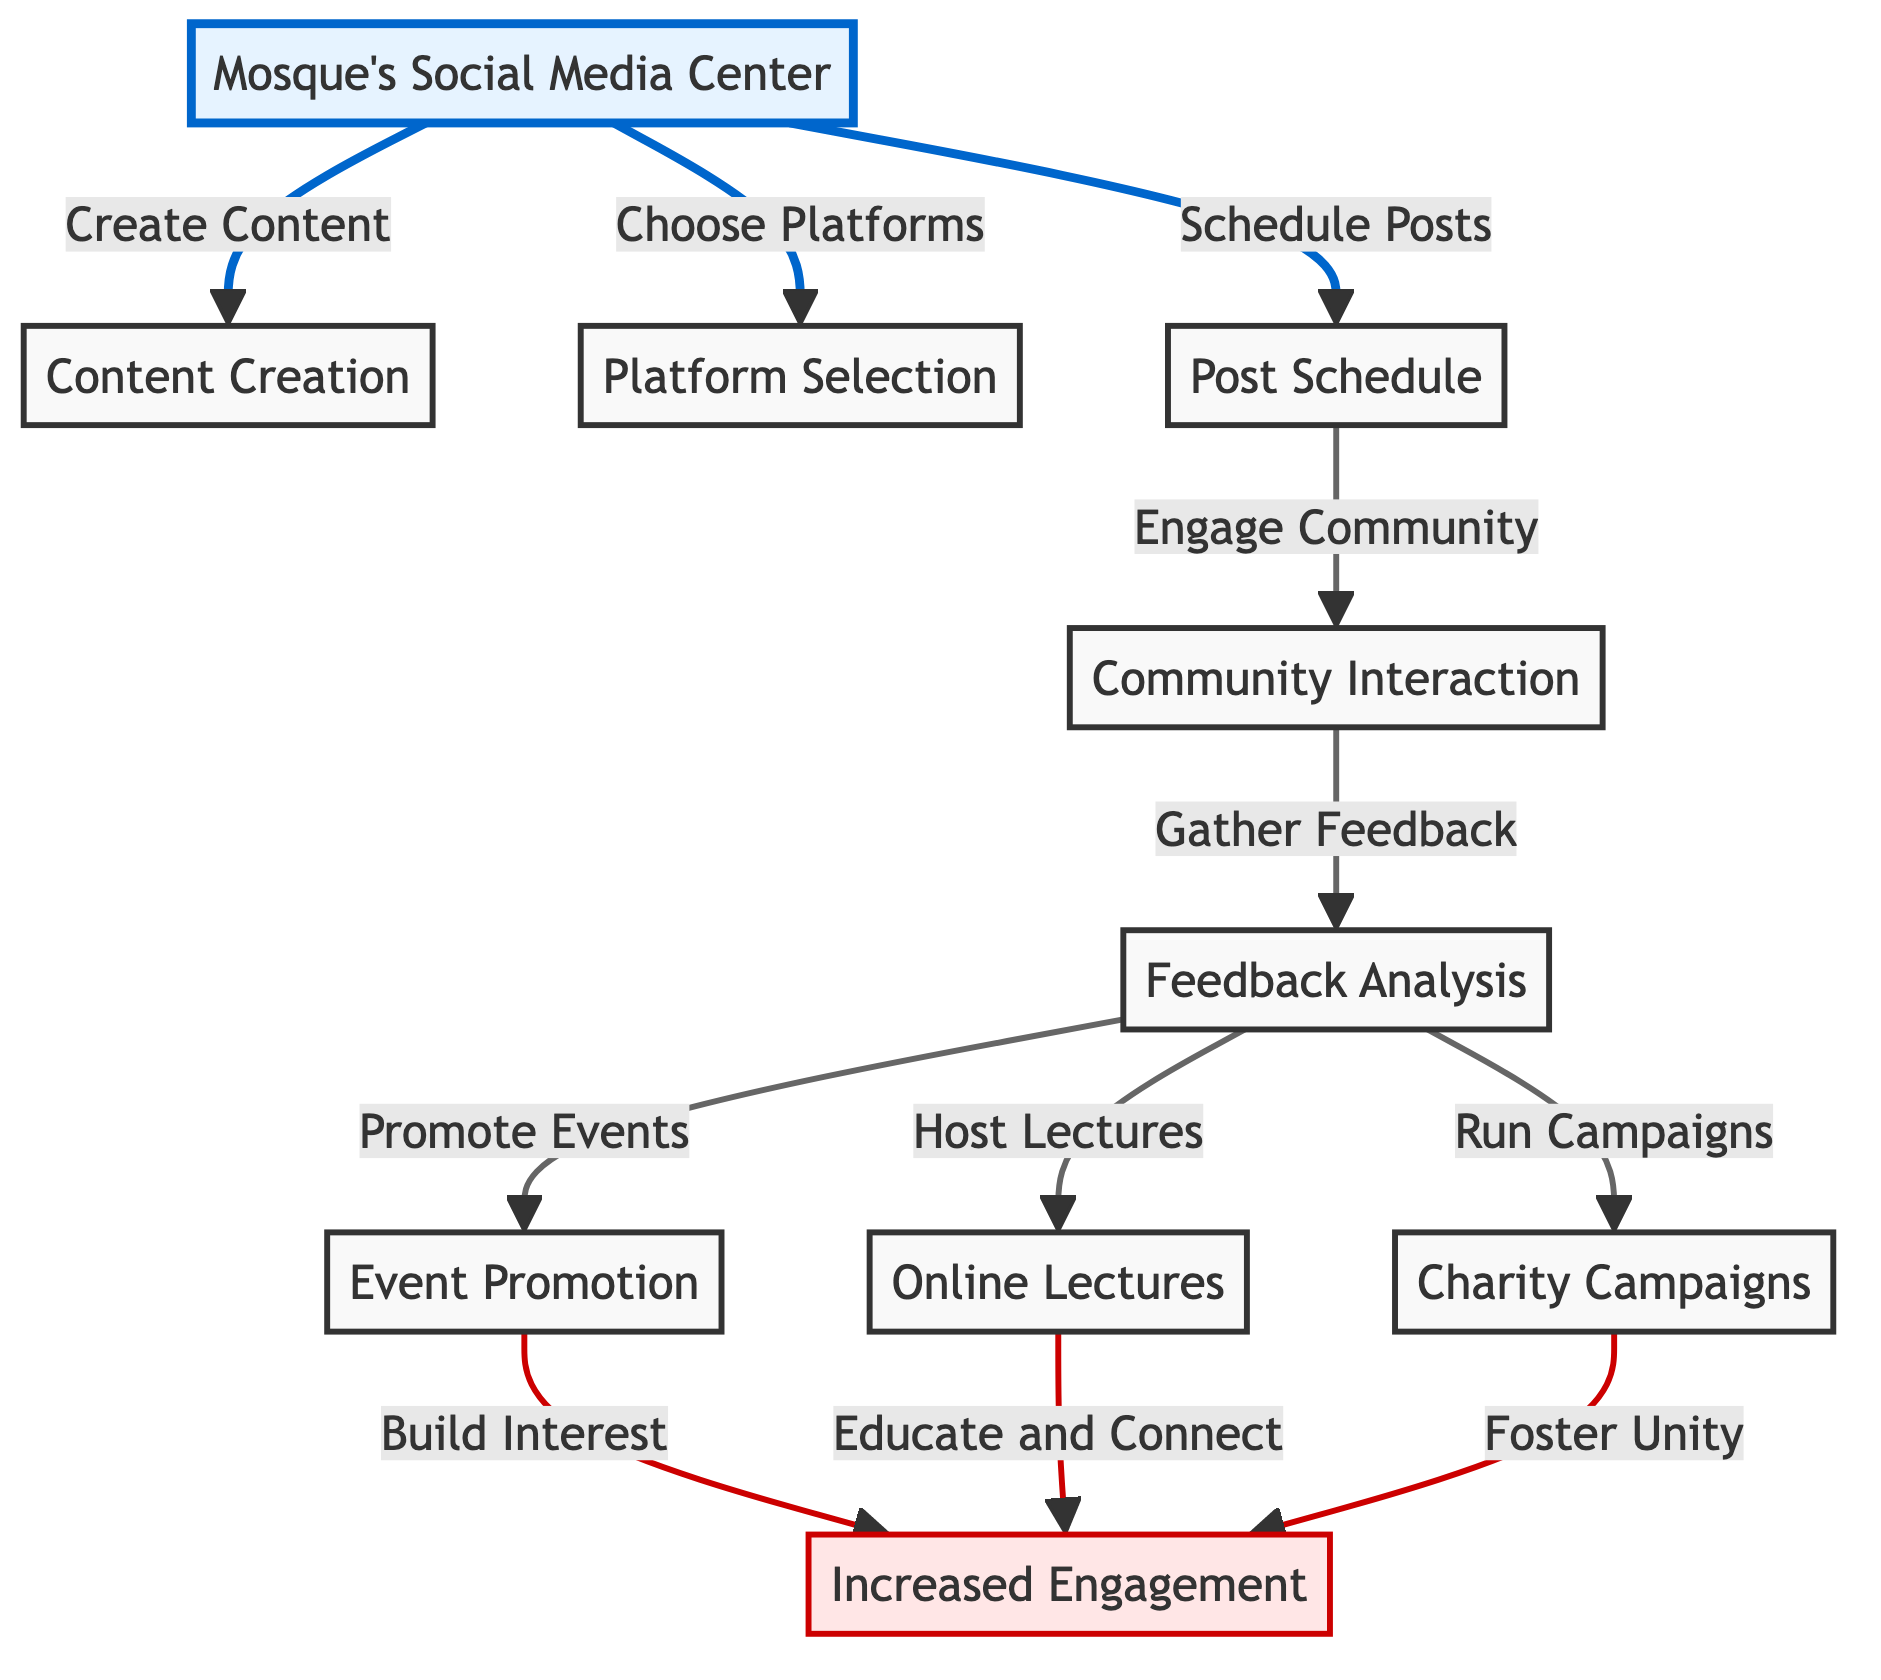What is the starting point of the diagram? The starting point of the diagram is the "Mosque's Social Media Center." This is indicated as the primary node from which the other activities emanate.
Answer: Mosque's Social Media Center How many activities follow after "Post Schedule"? After "Post Schedule," there are three activities: "Community Interaction," "Feedback Analysis," and "Event Promotion." Counting these gives a total of three activities directly connected to "Post Schedule."
Answer: 3 What does "Feedback Analysis" lead to in the diagram? "Feedback Analysis" leads to three activities: "Event Promotion," "Online Lectures," and "Charity Campaigns." These three nodes are the direct outputs of "Feedback Analysis."
Answer: Event Promotion, Online Lectures, Charity Campaigns What is the relationship between "Online Lectures" and "Increased Engagement"? "Online Lectures" leads to "Increased Engagement" as it states "Educate and Connect," indicating that hosting online lectures contributes to engaging the community more effectively.
Answer: Educate and Connect Which node is associated with “Foster Unity”? "Charity Campaigns" is the node associated with "Foster Unity," indicating that running charity campaigns is aimed at bringing the community together.
Answer: Charity Campaigns How many total nodes are in the diagram? By counting the primary nodes including "Mosque's Social Media Center," "Content Creation," "Platform Selection," "Post Schedule," "Community Interaction," "Feedback Analysis," "Event Promotion," "Online Lectures," "Charity Campaigns," and "Increased Engagement," we find a total of 10 nodes.
Answer: 10 What impacts "Increased Engagement"? "Increased Engagement" is impacted by three nodes: "Event Promotion," "Online Lectures," and "Charity Campaigns." Each of these nodes contributes to engagement through different means as illustrated in the diagram.
Answer: Event Promotion, Online Lectures, Charity Campaigns What is the last step in the process outlined in the diagram? The last step in the process is "Increased Engagement." It summarizes the overall impact of the previous activities on community involvement and participation.
Answer: Increased Engagement 